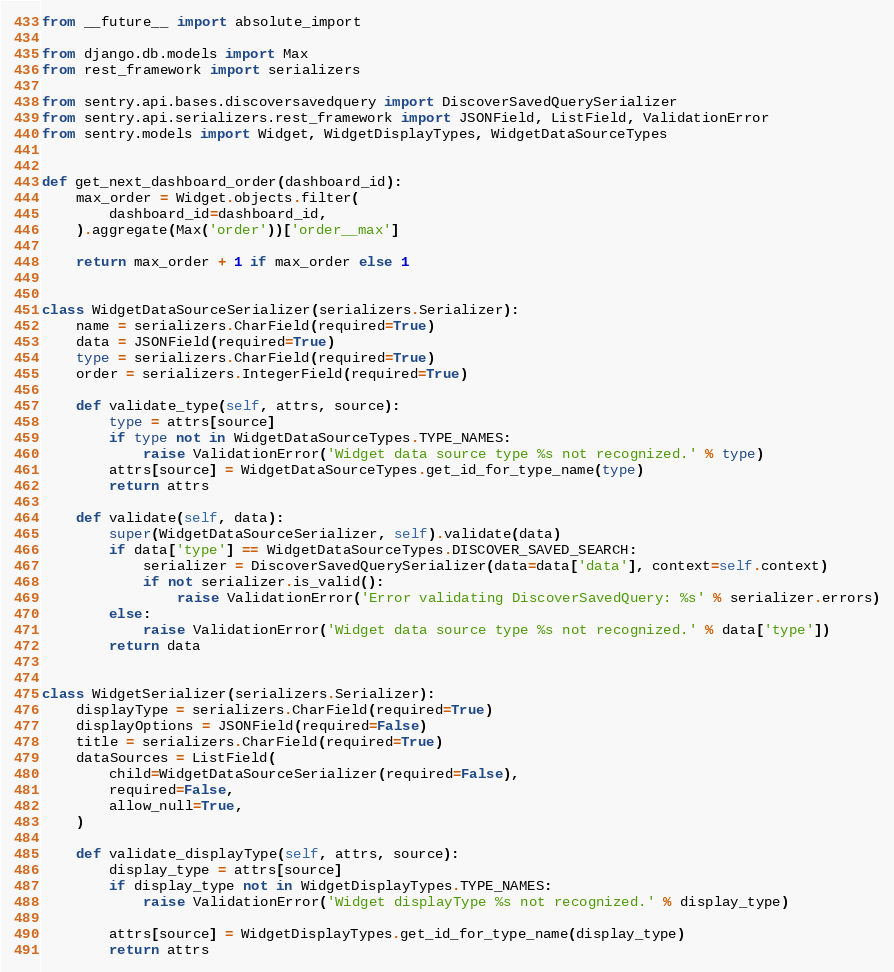Convert code to text. <code><loc_0><loc_0><loc_500><loc_500><_Python_>from __future__ import absolute_import

from django.db.models import Max
from rest_framework import serializers

from sentry.api.bases.discoversavedquery import DiscoverSavedQuerySerializer
from sentry.api.serializers.rest_framework import JSONField, ListField, ValidationError
from sentry.models import Widget, WidgetDisplayTypes, WidgetDataSourceTypes


def get_next_dashboard_order(dashboard_id):
    max_order = Widget.objects.filter(
        dashboard_id=dashboard_id,
    ).aggregate(Max('order'))['order__max']

    return max_order + 1 if max_order else 1


class WidgetDataSourceSerializer(serializers.Serializer):
    name = serializers.CharField(required=True)
    data = JSONField(required=True)
    type = serializers.CharField(required=True)
    order = serializers.IntegerField(required=True)

    def validate_type(self, attrs, source):
        type = attrs[source]
        if type not in WidgetDataSourceTypes.TYPE_NAMES:
            raise ValidationError('Widget data source type %s not recognized.' % type)
        attrs[source] = WidgetDataSourceTypes.get_id_for_type_name(type)
        return attrs

    def validate(self, data):
        super(WidgetDataSourceSerializer, self).validate(data)
        if data['type'] == WidgetDataSourceTypes.DISCOVER_SAVED_SEARCH:
            serializer = DiscoverSavedQuerySerializer(data=data['data'], context=self.context)
            if not serializer.is_valid():
                raise ValidationError('Error validating DiscoverSavedQuery: %s' % serializer.errors)
        else:
            raise ValidationError('Widget data source type %s not recognized.' % data['type'])
        return data


class WidgetSerializer(serializers.Serializer):
    displayType = serializers.CharField(required=True)
    displayOptions = JSONField(required=False)
    title = serializers.CharField(required=True)
    dataSources = ListField(
        child=WidgetDataSourceSerializer(required=False),
        required=False,
        allow_null=True,
    )

    def validate_displayType(self, attrs, source):
        display_type = attrs[source]
        if display_type not in WidgetDisplayTypes.TYPE_NAMES:
            raise ValidationError('Widget displayType %s not recognized.' % display_type)

        attrs[source] = WidgetDisplayTypes.get_id_for_type_name(display_type)
        return attrs
</code> 